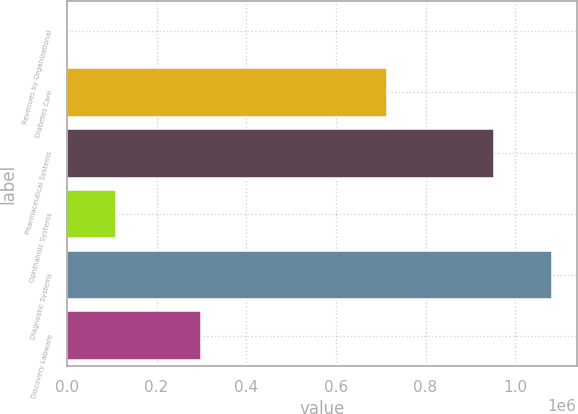Convert chart. <chart><loc_0><loc_0><loc_500><loc_500><bar_chart><fcel>Revenues by Organizational<fcel>Diabetes Care<fcel>Pharmaceutical Systems<fcel>Ophthalmic Systems<fcel>Diagnostic Systems<fcel>Discovery Labware<nl><fcel>2009<fcel>714937<fcel>952443<fcel>110087<fcel>1.08279e+06<fcel>299292<nl></chart> 